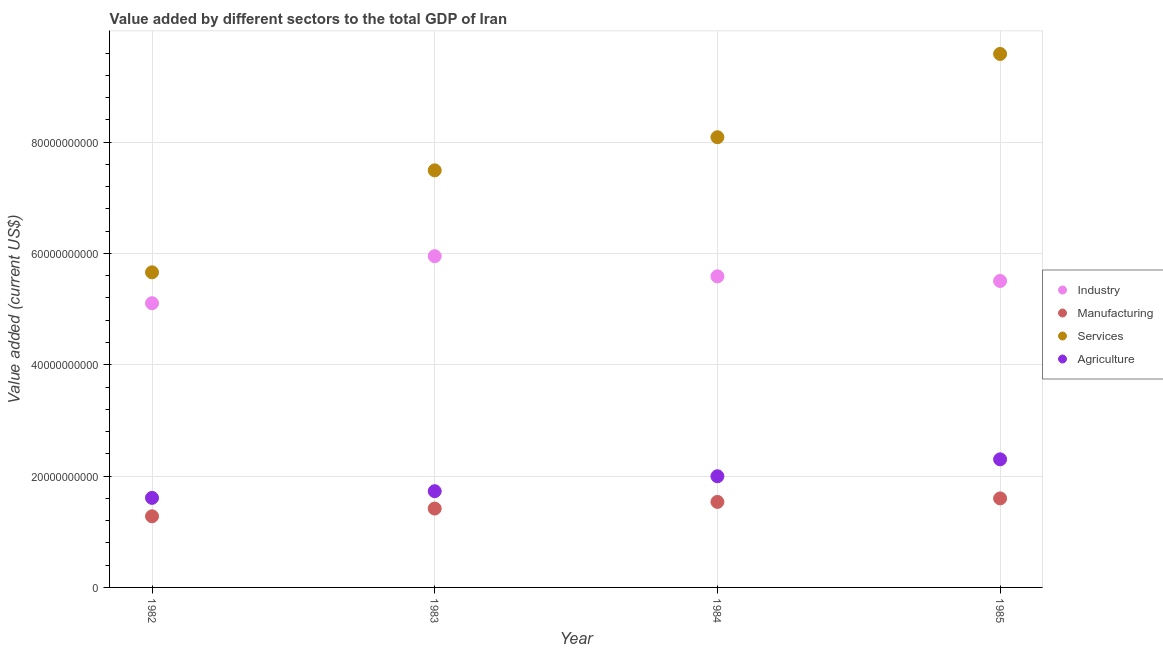Is the number of dotlines equal to the number of legend labels?
Your response must be concise. Yes. What is the value added by industrial sector in 1983?
Your response must be concise. 5.95e+1. Across all years, what is the maximum value added by agricultural sector?
Provide a succinct answer. 2.30e+1. Across all years, what is the minimum value added by agricultural sector?
Ensure brevity in your answer.  1.61e+1. In which year was the value added by industrial sector maximum?
Ensure brevity in your answer.  1983. In which year was the value added by agricultural sector minimum?
Your answer should be compact. 1982. What is the total value added by manufacturing sector in the graph?
Make the answer very short. 5.83e+1. What is the difference between the value added by manufacturing sector in 1984 and that in 1985?
Your response must be concise. -6.30e+08. What is the difference between the value added by agricultural sector in 1982 and the value added by services sector in 1984?
Make the answer very short. -6.48e+1. What is the average value added by agricultural sector per year?
Provide a succinct answer. 1.91e+1. In the year 1983, what is the difference between the value added by manufacturing sector and value added by agricultural sector?
Your answer should be very brief. -3.12e+09. In how many years, is the value added by agricultural sector greater than 88000000000 US$?
Give a very brief answer. 0. What is the ratio of the value added by agricultural sector in 1983 to that in 1984?
Offer a terse response. 0.87. What is the difference between the highest and the second highest value added by industrial sector?
Give a very brief answer. 3.62e+09. What is the difference between the highest and the lowest value added by agricultural sector?
Your response must be concise. 6.92e+09. In how many years, is the value added by manufacturing sector greater than the average value added by manufacturing sector taken over all years?
Your response must be concise. 2. Is it the case that in every year, the sum of the value added by industrial sector and value added by manufacturing sector is greater than the value added by services sector?
Provide a succinct answer. No. Is the value added by services sector strictly less than the value added by industrial sector over the years?
Keep it short and to the point. No. How many dotlines are there?
Provide a succinct answer. 4. What is the difference between two consecutive major ticks on the Y-axis?
Give a very brief answer. 2.00e+1. Are the values on the major ticks of Y-axis written in scientific E-notation?
Offer a terse response. No. Does the graph contain any zero values?
Your response must be concise. No. What is the title of the graph?
Provide a short and direct response. Value added by different sectors to the total GDP of Iran. What is the label or title of the Y-axis?
Your answer should be compact. Value added (current US$). What is the Value added (current US$) in Industry in 1982?
Offer a very short reply. 5.11e+1. What is the Value added (current US$) of Manufacturing in 1982?
Give a very brief answer. 1.28e+1. What is the Value added (current US$) of Services in 1982?
Provide a short and direct response. 5.66e+1. What is the Value added (current US$) of Agriculture in 1982?
Make the answer very short. 1.61e+1. What is the Value added (current US$) in Industry in 1983?
Ensure brevity in your answer.  5.95e+1. What is the Value added (current US$) of Manufacturing in 1983?
Offer a very short reply. 1.42e+1. What is the Value added (current US$) in Services in 1983?
Provide a short and direct response. 7.49e+1. What is the Value added (current US$) in Agriculture in 1983?
Ensure brevity in your answer.  1.73e+1. What is the Value added (current US$) of Industry in 1984?
Keep it short and to the point. 5.59e+1. What is the Value added (current US$) in Manufacturing in 1984?
Provide a succinct answer. 1.54e+1. What is the Value added (current US$) of Services in 1984?
Give a very brief answer. 8.09e+1. What is the Value added (current US$) of Agriculture in 1984?
Provide a succinct answer. 2.00e+1. What is the Value added (current US$) in Industry in 1985?
Keep it short and to the point. 5.51e+1. What is the Value added (current US$) in Manufacturing in 1985?
Give a very brief answer. 1.60e+1. What is the Value added (current US$) of Services in 1985?
Ensure brevity in your answer.  9.58e+1. What is the Value added (current US$) of Agriculture in 1985?
Give a very brief answer. 2.30e+1. Across all years, what is the maximum Value added (current US$) of Industry?
Offer a very short reply. 5.95e+1. Across all years, what is the maximum Value added (current US$) of Manufacturing?
Make the answer very short. 1.60e+1. Across all years, what is the maximum Value added (current US$) in Services?
Provide a short and direct response. 9.58e+1. Across all years, what is the maximum Value added (current US$) of Agriculture?
Keep it short and to the point. 2.30e+1. Across all years, what is the minimum Value added (current US$) of Industry?
Offer a terse response. 5.11e+1. Across all years, what is the minimum Value added (current US$) in Manufacturing?
Your response must be concise. 1.28e+1. Across all years, what is the minimum Value added (current US$) of Services?
Offer a very short reply. 5.66e+1. Across all years, what is the minimum Value added (current US$) of Agriculture?
Your response must be concise. 1.61e+1. What is the total Value added (current US$) of Industry in the graph?
Offer a very short reply. 2.22e+11. What is the total Value added (current US$) of Manufacturing in the graph?
Your response must be concise. 5.83e+1. What is the total Value added (current US$) of Services in the graph?
Provide a short and direct response. 3.08e+11. What is the total Value added (current US$) of Agriculture in the graph?
Offer a very short reply. 7.64e+1. What is the difference between the Value added (current US$) of Industry in 1982 and that in 1983?
Offer a very short reply. -8.45e+09. What is the difference between the Value added (current US$) of Manufacturing in 1982 and that in 1983?
Offer a very short reply. -1.39e+09. What is the difference between the Value added (current US$) in Services in 1982 and that in 1983?
Offer a very short reply. -1.83e+1. What is the difference between the Value added (current US$) of Agriculture in 1982 and that in 1983?
Provide a succinct answer. -1.20e+09. What is the difference between the Value added (current US$) in Industry in 1982 and that in 1984?
Provide a succinct answer. -4.83e+09. What is the difference between the Value added (current US$) of Manufacturing in 1982 and that in 1984?
Offer a very short reply. -2.59e+09. What is the difference between the Value added (current US$) in Services in 1982 and that in 1984?
Make the answer very short. -2.43e+1. What is the difference between the Value added (current US$) of Agriculture in 1982 and that in 1984?
Your answer should be compact. -3.88e+09. What is the difference between the Value added (current US$) in Industry in 1982 and that in 1985?
Offer a terse response. -4.00e+09. What is the difference between the Value added (current US$) of Manufacturing in 1982 and that in 1985?
Keep it short and to the point. -3.22e+09. What is the difference between the Value added (current US$) of Services in 1982 and that in 1985?
Offer a very short reply. -3.92e+1. What is the difference between the Value added (current US$) of Agriculture in 1982 and that in 1985?
Your answer should be compact. -6.92e+09. What is the difference between the Value added (current US$) of Industry in 1983 and that in 1984?
Your response must be concise. 3.62e+09. What is the difference between the Value added (current US$) of Manufacturing in 1983 and that in 1984?
Provide a short and direct response. -1.19e+09. What is the difference between the Value added (current US$) in Services in 1983 and that in 1984?
Ensure brevity in your answer.  -5.95e+09. What is the difference between the Value added (current US$) in Agriculture in 1983 and that in 1984?
Offer a terse response. -2.68e+09. What is the difference between the Value added (current US$) in Industry in 1983 and that in 1985?
Your answer should be very brief. 4.46e+09. What is the difference between the Value added (current US$) in Manufacturing in 1983 and that in 1985?
Offer a terse response. -1.82e+09. What is the difference between the Value added (current US$) in Services in 1983 and that in 1985?
Offer a very short reply. -2.09e+1. What is the difference between the Value added (current US$) of Agriculture in 1983 and that in 1985?
Keep it short and to the point. -5.72e+09. What is the difference between the Value added (current US$) of Industry in 1984 and that in 1985?
Offer a very short reply. 8.32e+08. What is the difference between the Value added (current US$) of Manufacturing in 1984 and that in 1985?
Offer a terse response. -6.30e+08. What is the difference between the Value added (current US$) of Services in 1984 and that in 1985?
Make the answer very short. -1.50e+1. What is the difference between the Value added (current US$) of Agriculture in 1984 and that in 1985?
Provide a succinct answer. -3.04e+09. What is the difference between the Value added (current US$) of Industry in 1982 and the Value added (current US$) of Manufacturing in 1983?
Your answer should be compact. 3.69e+1. What is the difference between the Value added (current US$) of Industry in 1982 and the Value added (current US$) of Services in 1983?
Keep it short and to the point. -2.39e+1. What is the difference between the Value added (current US$) of Industry in 1982 and the Value added (current US$) of Agriculture in 1983?
Ensure brevity in your answer.  3.38e+1. What is the difference between the Value added (current US$) in Manufacturing in 1982 and the Value added (current US$) in Services in 1983?
Your response must be concise. -6.22e+1. What is the difference between the Value added (current US$) of Manufacturing in 1982 and the Value added (current US$) of Agriculture in 1983?
Give a very brief answer. -4.51e+09. What is the difference between the Value added (current US$) of Services in 1982 and the Value added (current US$) of Agriculture in 1983?
Provide a succinct answer. 3.93e+1. What is the difference between the Value added (current US$) in Industry in 1982 and the Value added (current US$) in Manufacturing in 1984?
Offer a terse response. 3.57e+1. What is the difference between the Value added (current US$) in Industry in 1982 and the Value added (current US$) in Services in 1984?
Ensure brevity in your answer.  -2.98e+1. What is the difference between the Value added (current US$) in Industry in 1982 and the Value added (current US$) in Agriculture in 1984?
Your answer should be compact. 3.11e+1. What is the difference between the Value added (current US$) in Manufacturing in 1982 and the Value added (current US$) in Services in 1984?
Offer a terse response. -6.81e+1. What is the difference between the Value added (current US$) in Manufacturing in 1982 and the Value added (current US$) in Agriculture in 1984?
Give a very brief answer. -7.20e+09. What is the difference between the Value added (current US$) of Services in 1982 and the Value added (current US$) of Agriculture in 1984?
Make the answer very short. 3.66e+1. What is the difference between the Value added (current US$) in Industry in 1982 and the Value added (current US$) in Manufacturing in 1985?
Make the answer very short. 3.51e+1. What is the difference between the Value added (current US$) in Industry in 1982 and the Value added (current US$) in Services in 1985?
Your answer should be very brief. -4.48e+1. What is the difference between the Value added (current US$) in Industry in 1982 and the Value added (current US$) in Agriculture in 1985?
Offer a very short reply. 2.80e+1. What is the difference between the Value added (current US$) of Manufacturing in 1982 and the Value added (current US$) of Services in 1985?
Give a very brief answer. -8.31e+1. What is the difference between the Value added (current US$) in Manufacturing in 1982 and the Value added (current US$) in Agriculture in 1985?
Offer a terse response. -1.02e+1. What is the difference between the Value added (current US$) of Services in 1982 and the Value added (current US$) of Agriculture in 1985?
Your response must be concise. 3.36e+1. What is the difference between the Value added (current US$) in Industry in 1983 and the Value added (current US$) in Manufacturing in 1984?
Your response must be concise. 4.41e+1. What is the difference between the Value added (current US$) of Industry in 1983 and the Value added (current US$) of Services in 1984?
Give a very brief answer. -2.14e+1. What is the difference between the Value added (current US$) of Industry in 1983 and the Value added (current US$) of Agriculture in 1984?
Your answer should be compact. 3.95e+1. What is the difference between the Value added (current US$) of Manufacturing in 1983 and the Value added (current US$) of Services in 1984?
Offer a very short reply. -6.67e+1. What is the difference between the Value added (current US$) in Manufacturing in 1983 and the Value added (current US$) in Agriculture in 1984?
Keep it short and to the point. -5.80e+09. What is the difference between the Value added (current US$) in Services in 1983 and the Value added (current US$) in Agriculture in 1984?
Your answer should be compact. 5.50e+1. What is the difference between the Value added (current US$) of Industry in 1983 and the Value added (current US$) of Manufacturing in 1985?
Provide a succinct answer. 4.35e+1. What is the difference between the Value added (current US$) in Industry in 1983 and the Value added (current US$) in Services in 1985?
Make the answer very short. -3.63e+1. What is the difference between the Value added (current US$) in Industry in 1983 and the Value added (current US$) in Agriculture in 1985?
Your answer should be very brief. 3.65e+1. What is the difference between the Value added (current US$) of Manufacturing in 1983 and the Value added (current US$) of Services in 1985?
Give a very brief answer. -8.17e+1. What is the difference between the Value added (current US$) of Manufacturing in 1983 and the Value added (current US$) of Agriculture in 1985?
Provide a short and direct response. -8.84e+09. What is the difference between the Value added (current US$) in Services in 1983 and the Value added (current US$) in Agriculture in 1985?
Keep it short and to the point. 5.19e+1. What is the difference between the Value added (current US$) in Industry in 1984 and the Value added (current US$) in Manufacturing in 1985?
Offer a very short reply. 3.99e+1. What is the difference between the Value added (current US$) in Industry in 1984 and the Value added (current US$) in Services in 1985?
Your response must be concise. -4.00e+1. What is the difference between the Value added (current US$) in Industry in 1984 and the Value added (current US$) in Agriculture in 1985?
Make the answer very short. 3.29e+1. What is the difference between the Value added (current US$) of Manufacturing in 1984 and the Value added (current US$) of Services in 1985?
Offer a very short reply. -8.05e+1. What is the difference between the Value added (current US$) in Manufacturing in 1984 and the Value added (current US$) in Agriculture in 1985?
Offer a very short reply. -7.65e+09. What is the difference between the Value added (current US$) in Services in 1984 and the Value added (current US$) in Agriculture in 1985?
Offer a terse response. 5.79e+1. What is the average Value added (current US$) of Industry per year?
Offer a very short reply. 5.54e+1. What is the average Value added (current US$) of Manufacturing per year?
Provide a short and direct response. 1.46e+1. What is the average Value added (current US$) of Services per year?
Ensure brevity in your answer.  7.71e+1. What is the average Value added (current US$) of Agriculture per year?
Provide a succinct answer. 1.91e+1. In the year 1982, what is the difference between the Value added (current US$) in Industry and Value added (current US$) in Manufacturing?
Your answer should be compact. 3.83e+1. In the year 1982, what is the difference between the Value added (current US$) in Industry and Value added (current US$) in Services?
Offer a very short reply. -5.55e+09. In the year 1982, what is the difference between the Value added (current US$) in Industry and Value added (current US$) in Agriculture?
Your answer should be very brief. 3.50e+1. In the year 1982, what is the difference between the Value added (current US$) in Manufacturing and Value added (current US$) in Services?
Your answer should be compact. -4.38e+1. In the year 1982, what is the difference between the Value added (current US$) of Manufacturing and Value added (current US$) of Agriculture?
Make the answer very short. -3.31e+09. In the year 1982, what is the difference between the Value added (current US$) of Services and Value added (current US$) of Agriculture?
Offer a terse response. 4.05e+1. In the year 1983, what is the difference between the Value added (current US$) in Industry and Value added (current US$) in Manufacturing?
Ensure brevity in your answer.  4.53e+1. In the year 1983, what is the difference between the Value added (current US$) of Industry and Value added (current US$) of Services?
Ensure brevity in your answer.  -1.54e+1. In the year 1983, what is the difference between the Value added (current US$) in Industry and Value added (current US$) in Agriculture?
Give a very brief answer. 4.22e+1. In the year 1983, what is the difference between the Value added (current US$) of Manufacturing and Value added (current US$) of Services?
Make the answer very short. -6.08e+1. In the year 1983, what is the difference between the Value added (current US$) of Manufacturing and Value added (current US$) of Agriculture?
Make the answer very short. -3.12e+09. In the year 1983, what is the difference between the Value added (current US$) of Services and Value added (current US$) of Agriculture?
Provide a short and direct response. 5.76e+1. In the year 1984, what is the difference between the Value added (current US$) in Industry and Value added (current US$) in Manufacturing?
Offer a terse response. 4.05e+1. In the year 1984, what is the difference between the Value added (current US$) of Industry and Value added (current US$) of Services?
Your answer should be compact. -2.50e+1. In the year 1984, what is the difference between the Value added (current US$) of Industry and Value added (current US$) of Agriculture?
Offer a very short reply. 3.59e+1. In the year 1984, what is the difference between the Value added (current US$) in Manufacturing and Value added (current US$) in Services?
Your answer should be very brief. -6.55e+1. In the year 1984, what is the difference between the Value added (current US$) of Manufacturing and Value added (current US$) of Agriculture?
Keep it short and to the point. -4.61e+09. In the year 1984, what is the difference between the Value added (current US$) of Services and Value added (current US$) of Agriculture?
Ensure brevity in your answer.  6.09e+1. In the year 1985, what is the difference between the Value added (current US$) of Industry and Value added (current US$) of Manufacturing?
Keep it short and to the point. 3.91e+1. In the year 1985, what is the difference between the Value added (current US$) of Industry and Value added (current US$) of Services?
Offer a very short reply. -4.08e+1. In the year 1985, what is the difference between the Value added (current US$) of Industry and Value added (current US$) of Agriculture?
Your answer should be compact. 3.20e+1. In the year 1985, what is the difference between the Value added (current US$) of Manufacturing and Value added (current US$) of Services?
Provide a succinct answer. -7.98e+1. In the year 1985, what is the difference between the Value added (current US$) of Manufacturing and Value added (current US$) of Agriculture?
Make the answer very short. -7.02e+09. In the year 1985, what is the difference between the Value added (current US$) of Services and Value added (current US$) of Agriculture?
Offer a terse response. 7.28e+1. What is the ratio of the Value added (current US$) in Industry in 1982 to that in 1983?
Offer a terse response. 0.86. What is the ratio of the Value added (current US$) in Manufacturing in 1982 to that in 1983?
Offer a terse response. 0.9. What is the ratio of the Value added (current US$) of Services in 1982 to that in 1983?
Provide a short and direct response. 0.76. What is the ratio of the Value added (current US$) in Agriculture in 1982 to that in 1983?
Give a very brief answer. 0.93. What is the ratio of the Value added (current US$) of Industry in 1982 to that in 1984?
Your answer should be compact. 0.91. What is the ratio of the Value added (current US$) of Manufacturing in 1982 to that in 1984?
Give a very brief answer. 0.83. What is the ratio of the Value added (current US$) in Services in 1982 to that in 1984?
Offer a terse response. 0.7. What is the ratio of the Value added (current US$) of Agriculture in 1982 to that in 1984?
Give a very brief answer. 0.81. What is the ratio of the Value added (current US$) of Industry in 1982 to that in 1985?
Your answer should be compact. 0.93. What is the ratio of the Value added (current US$) in Manufacturing in 1982 to that in 1985?
Offer a terse response. 0.8. What is the ratio of the Value added (current US$) in Services in 1982 to that in 1985?
Give a very brief answer. 0.59. What is the ratio of the Value added (current US$) of Agriculture in 1982 to that in 1985?
Offer a very short reply. 0.7. What is the ratio of the Value added (current US$) in Industry in 1983 to that in 1984?
Your answer should be very brief. 1.06. What is the ratio of the Value added (current US$) in Manufacturing in 1983 to that in 1984?
Keep it short and to the point. 0.92. What is the ratio of the Value added (current US$) in Services in 1983 to that in 1984?
Your answer should be compact. 0.93. What is the ratio of the Value added (current US$) in Agriculture in 1983 to that in 1984?
Your answer should be compact. 0.87. What is the ratio of the Value added (current US$) in Industry in 1983 to that in 1985?
Keep it short and to the point. 1.08. What is the ratio of the Value added (current US$) of Manufacturing in 1983 to that in 1985?
Offer a terse response. 0.89. What is the ratio of the Value added (current US$) of Services in 1983 to that in 1985?
Offer a very short reply. 0.78. What is the ratio of the Value added (current US$) of Agriculture in 1983 to that in 1985?
Provide a short and direct response. 0.75. What is the ratio of the Value added (current US$) in Industry in 1984 to that in 1985?
Give a very brief answer. 1.02. What is the ratio of the Value added (current US$) of Manufacturing in 1984 to that in 1985?
Give a very brief answer. 0.96. What is the ratio of the Value added (current US$) of Services in 1984 to that in 1985?
Your answer should be compact. 0.84. What is the ratio of the Value added (current US$) in Agriculture in 1984 to that in 1985?
Your answer should be compact. 0.87. What is the difference between the highest and the second highest Value added (current US$) in Industry?
Provide a short and direct response. 3.62e+09. What is the difference between the highest and the second highest Value added (current US$) in Manufacturing?
Keep it short and to the point. 6.30e+08. What is the difference between the highest and the second highest Value added (current US$) in Services?
Make the answer very short. 1.50e+1. What is the difference between the highest and the second highest Value added (current US$) in Agriculture?
Give a very brief answer. 3.04e+09. What is the difference between the highest and the lowest Value added (current US$) of Industry?
Make the answer very short. 8.45e+09. What is the difference between the highest and the lowest Value added (current US$) of Manufacturing?
Provide a succinct answer. 3.22e+09. What is the difference between the highest and the lowest Value added (current US$) in Services?
Your response must be concise. 3.92e+1. What is the difference between the highest and the lowest Value added (current US$) of Agriculture?
Give a very brief answer. 6.92e+09. 